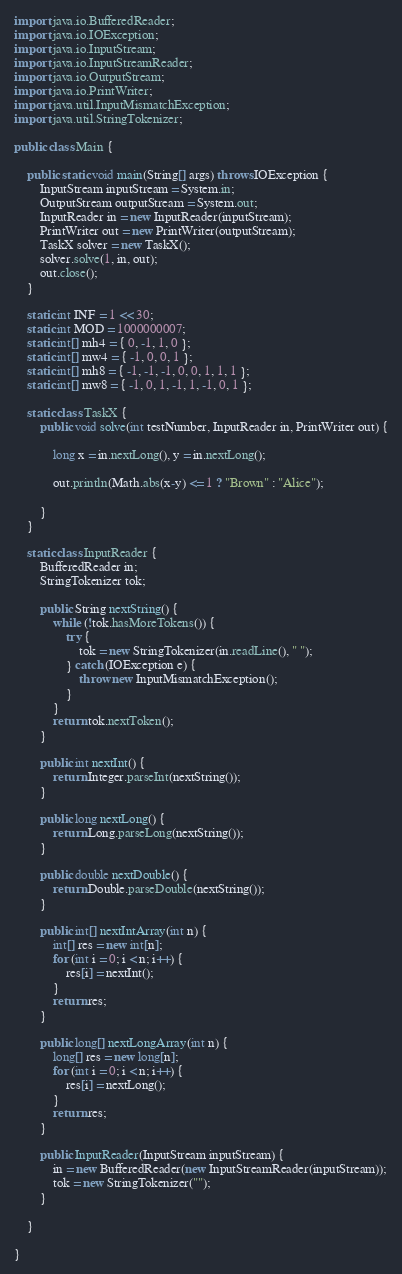Convert code to text. <code><loc_0><loc_0><loc_500><loc_500><_Java_>
import java.io.BufferedReader;
import java.io.IOException;
import java.io.InputStream;
import java.io.InputStreamReader;
import java.io.OutputStream;
import java.io.PrintWriter;
import java.util.InputMismatchException;
import java.util.StringTokenizer;

public class Main {

	public static void main(String[] args) throws IOException {
		InputStream inputStream = System.in;
		OutputStream outputStream = System.out;
		InputReader in = new InputReader(inputStream);
		PrintWriter out = new PrintWriter(outputStream);
		TaskX solver = new TaskX();
		solver.solve(1, in, out);
		out.close();
	}

	static int INF = 1 << 30;
	static int MOD = 1000000007;
	static int[] mh4 = { 0, -1, 1, 0 };
	static int[] mw4 = { -1, 0, 0, 1 };
	static int[] mh8 = { -1, -1, -1, 0, 0, 1, 1, 1 };
	static int[] mw8 = { -1, 0, 1, -1, 1, -1, 0, 1 };

	static class TaskX {
		public void solve(int testNumber, InputReader in, PrintWriter out) {

			long x = in.nextLong(), y = in.nextLong();

			out.println(Math.abs(x-y) <= 1 ? "Brown" : "Alice");

		}
	}

	static class InputReader {
		BufferedReader in;
		StringTokenizer tok;

		public String nextString() {
			while (!tok.hasMoreTokens()) {
				try {
					tok = new StringTokenizer(in.readLine(), " ");
				} catch (IOException e) {
					throw new InputMismatchException();
				}
			}
			return tok.nextToken();
		}

		public int nextInt() {
			return Integer.parseInt(nextString());
		}

		public long nextLong() {
			return Long.parseLong(nextString());
		}

		public double nextDouble() {
			return Double.parseDouble(nextString());
		}

		public int[] nextIntArray(int n) {
			int[] res = new int[n];
			for (int i = 0; i < n; i++) {
				res[i] = nextInt();
			}
			return res;
		}

		public long[] nextLongArray(int n) {
			long[] res = new long[n];
			for (int i = 0; i < n; i++) {
				res[i] = nextLong();
			}
			return res;
		}

		public InputReader(InputStream inputStream) {
			in = new BufferedReader(new InputStreamReader(inputStream));
			tok = new StringTokenizer("");
		}

	}

}
</code> 